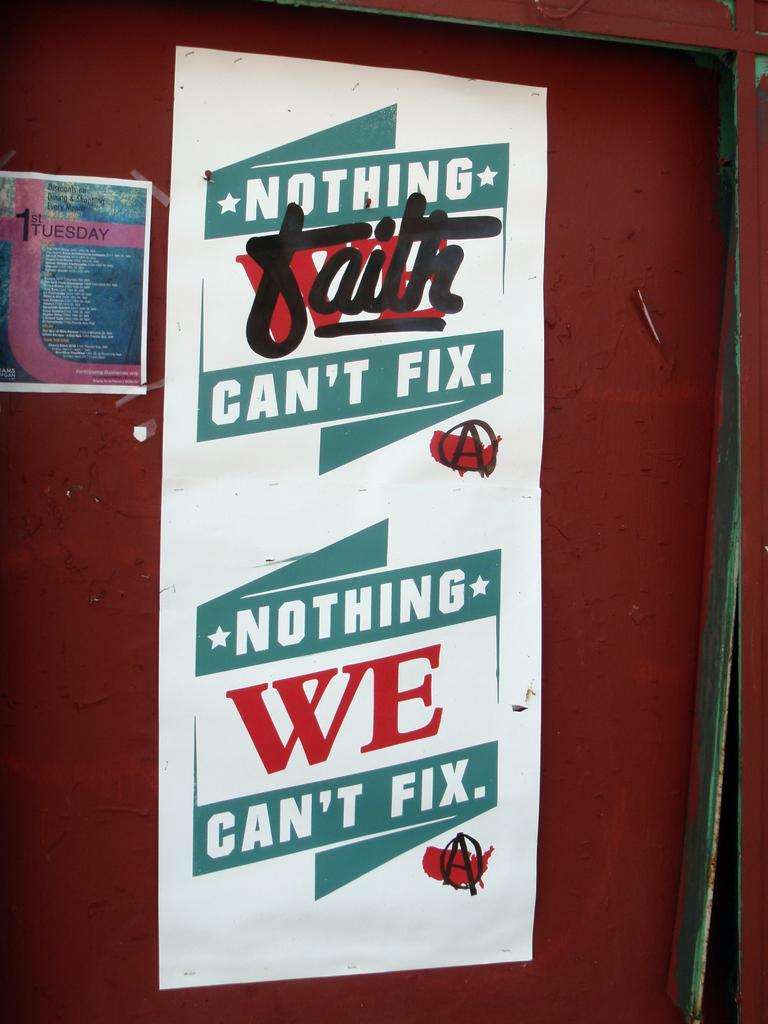What is the color of the surface visible in the image? The surface visible in the image is brown-colored. What structures are attached to the surface? There are two posts attached to the surface. What type of spot can be seen on the surface in the image? There is no spot visible on the surface in the image. What is the income of the person who owns the surface in the image? The income of the person who owns the surface is not mentioned or visible in the image. What type of air is present around the surface in the image? The type of air present around the surface is not mentioned or visible in the image. 